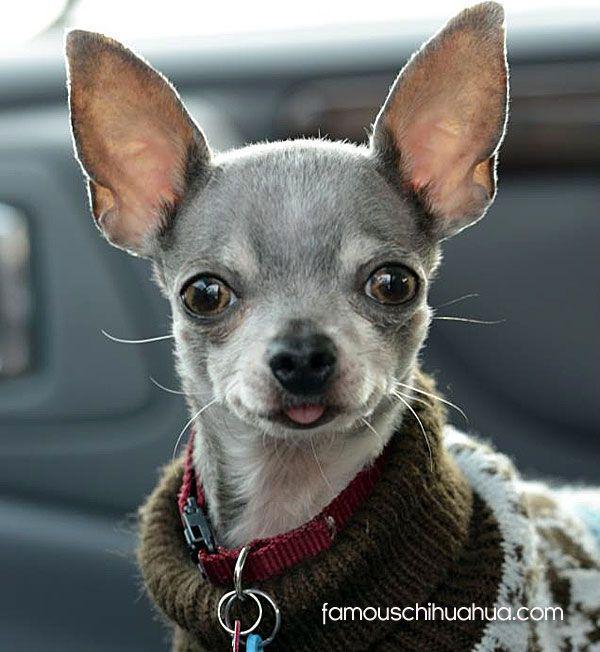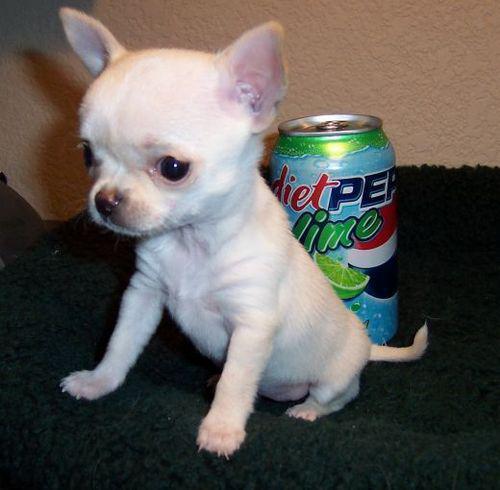The first image is the image on the left, the second image is the image on the right. Considering the images on both sides, is "One of the dogs is sticking it's tongue out of a closed mouth." valid? Answer yes or no. Yes. 